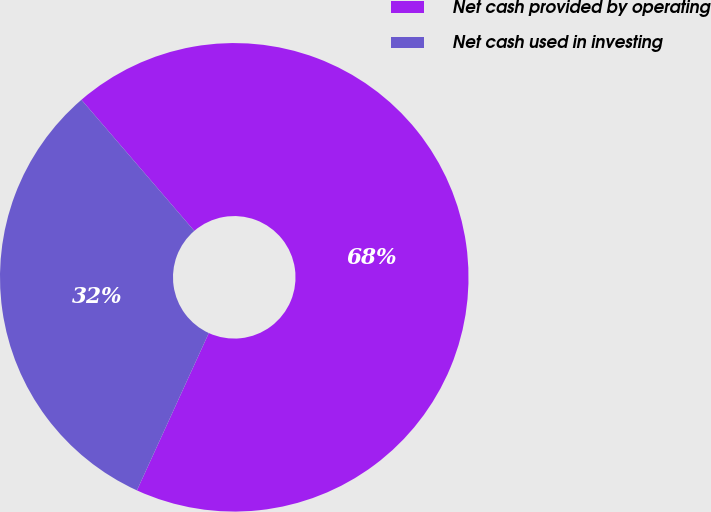Convert chart. <chart><loc_0><loc_0><loc_500><loc_500><pie_chart><fcel>Net cash provided by operating<fcel>Net cash used in investing<nl><fcel>68.13%<fcel>31.87%<nl></chart> 